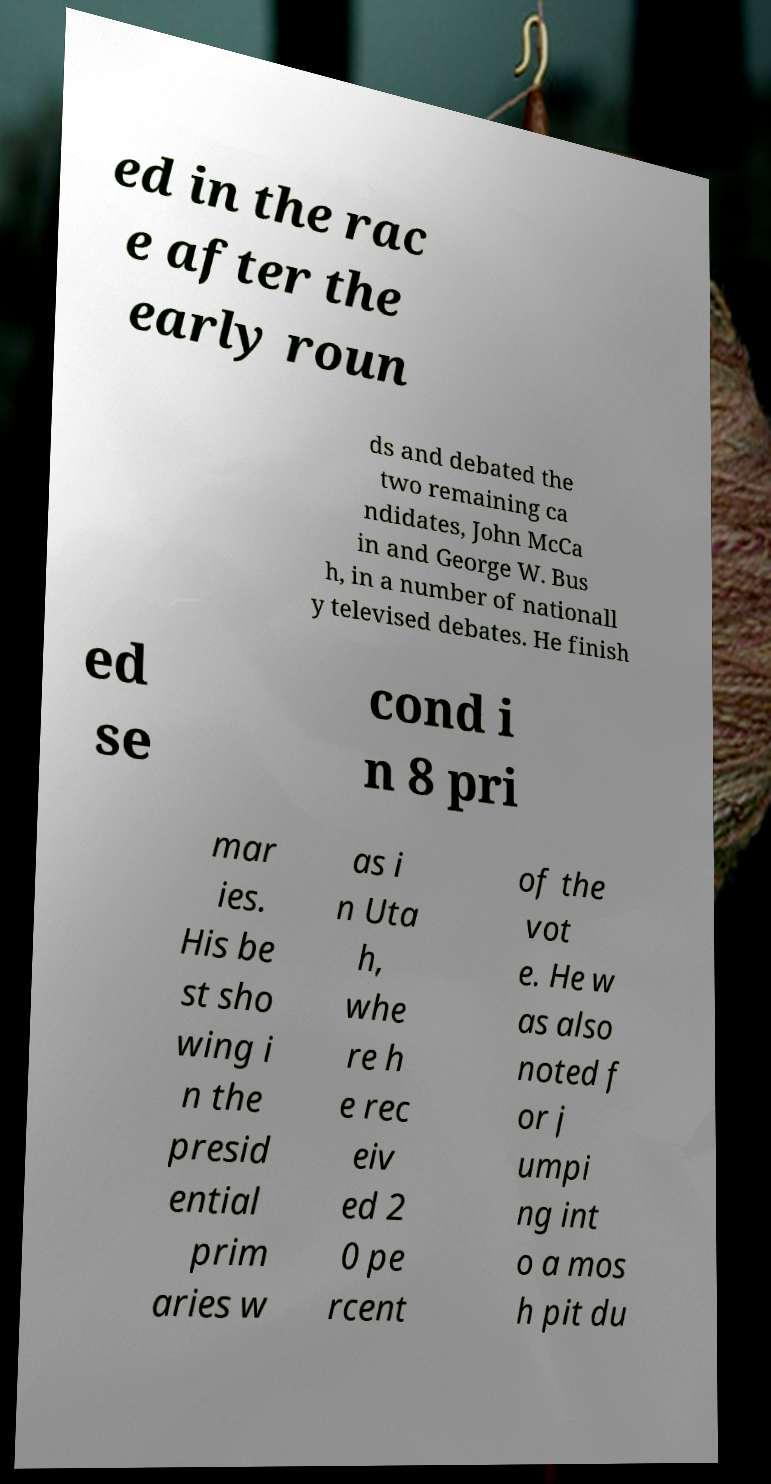Could you assist in decoding the text presented in this image and type it out clearly? ed in the rac e after the early roun ds and debated the two remaining ca ndidates, John McCa in and George W. Bus h, in a number of nationall y televised debates. He finish ed se cond i n 8 pri mar ies. His be st sho wing i n the presid ential prim aries w as i n Uta h, whe re h e rec eiv ed 2 0 pe rcent of the vot e. He w as also noted f or j umpi ng int o a mos h pit du 